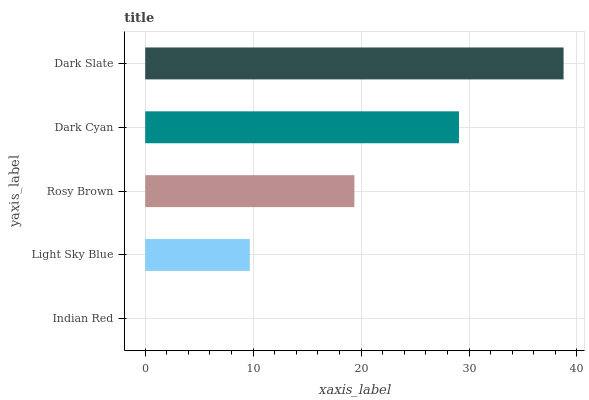Is Indian Red the minimum?
Answer yes or no. Yes. Is Dark Slate the maximum?
Answer yes or no. Yes. Is Light Sky Blue the minimum?
Answer yes or no. No. Is Light Sky Blue the maximum?
Answer yes or no. No. Is Light Sky Blue greater than Indian Red?
Answer yes or no. Yes. Is Indian Red less than Light Sky Blue?
Answer yes or no. Yes. Is Indian Red greater than Light Sky Blue?
Answer yes or no. No. Is Light Sky Blue less than Indian Red?
Answer yes or no. No. Is Rosy Brown the high median?
Answer yes or no. Yes. Is Rosy Brown the low median?
Answer yes or no. Yes. Is Dark Cyan the high median?
Answer yes or no. No. Is Indian Red the low median?
Answer yes or no. No. 